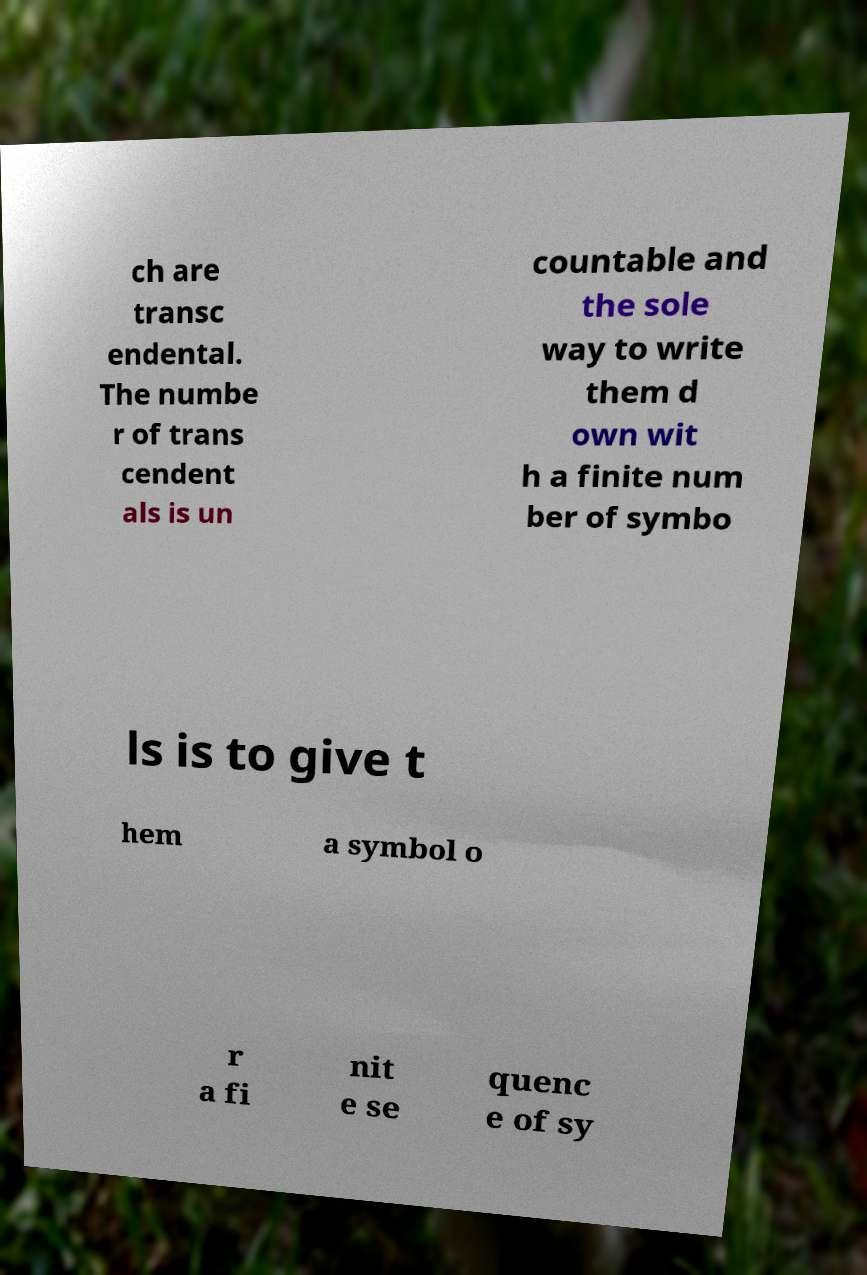I need the written content from this picture converted into text. Can you do that? ch are transc endental. The numbe r of trans cendent als is un countable and the sole way to write them d own wit h a finite num ber of symbo ls is to give t hem a symbol o r a fi nit e se quenc e of sy 